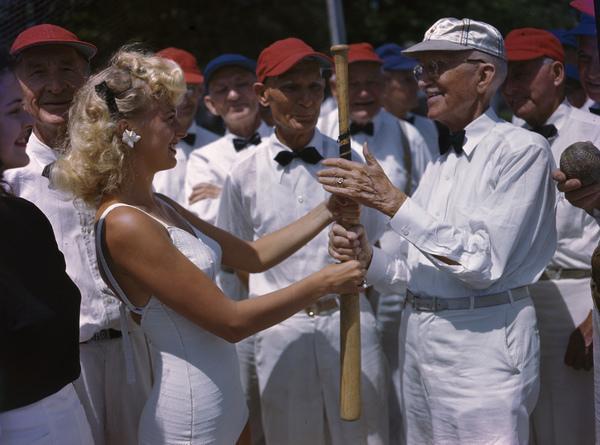How many people are visible?
Give a very brief answer. 10. 